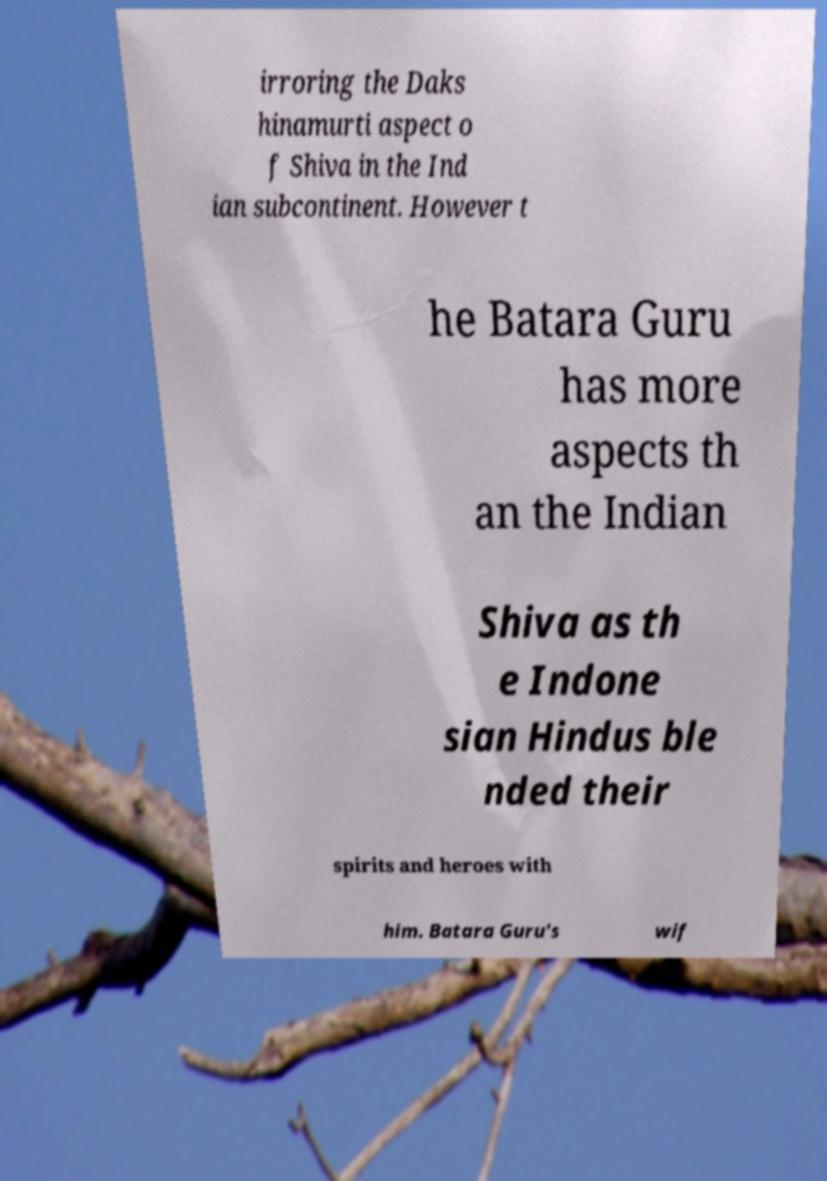Could you assist in decoding the text presented in this image and type it out clearly? irroring the Daks hinamurti aspect o f Shiva in the Ind ian subcontinent. However t he Batara Guru has more aspects th an the Indian Shiva as th e Indone sian Hindus ble nded their spirits and heroes with him. Batara Guru's wif 